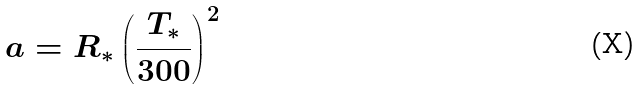<formula> <loc_0><loc_0><loc_500><loc_500>a = R _ { * } \left ( \frac { T _ { * } } { 3 0 0 } \right ) ^ { 2 }</formula> 